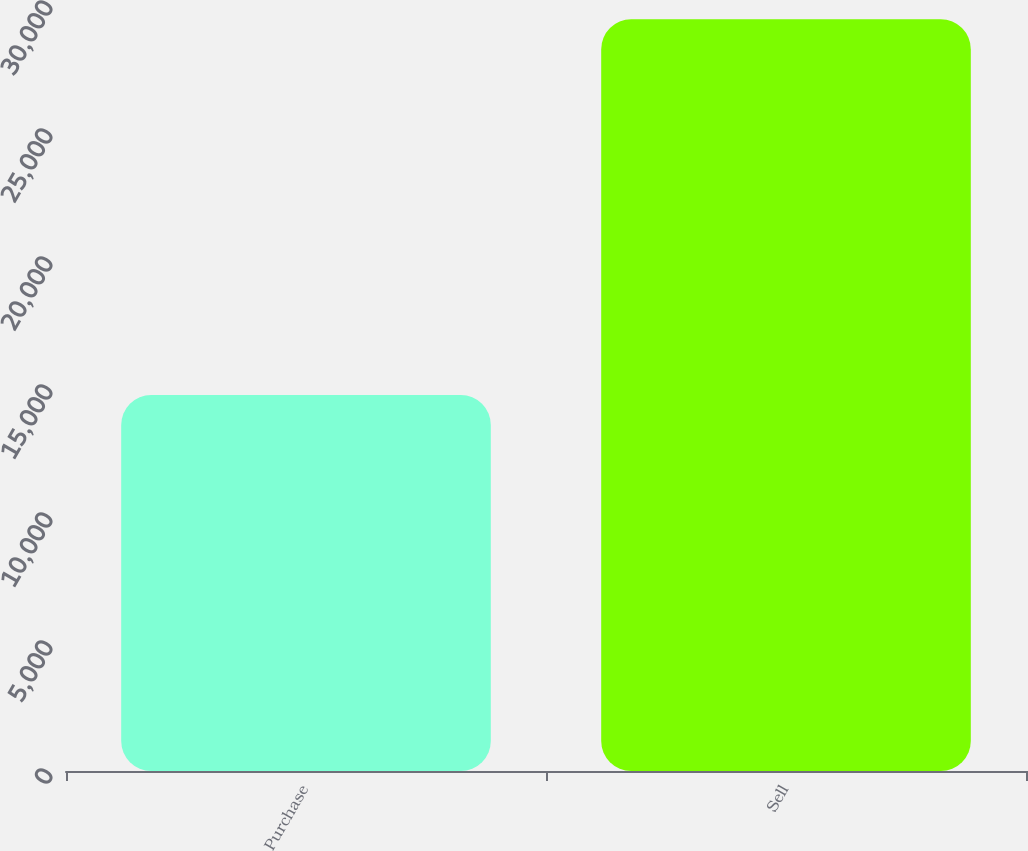Convert chart. <chart><loc_0><loc_0><loc_500><loc_500><bar_chart><fcel>Purchase<fcel>Sell<nl><fcel>14689<fcel>29362<nl></chart> 